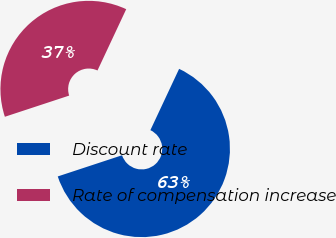Convert chart. <chart><loc_0><loc_0><loc_500><loc_500><pie_chart><fcel>Discount rate<fcel>Rate of compensation increase<nl><fcel>62.96%<fcel>37.04%<nl></chart> 